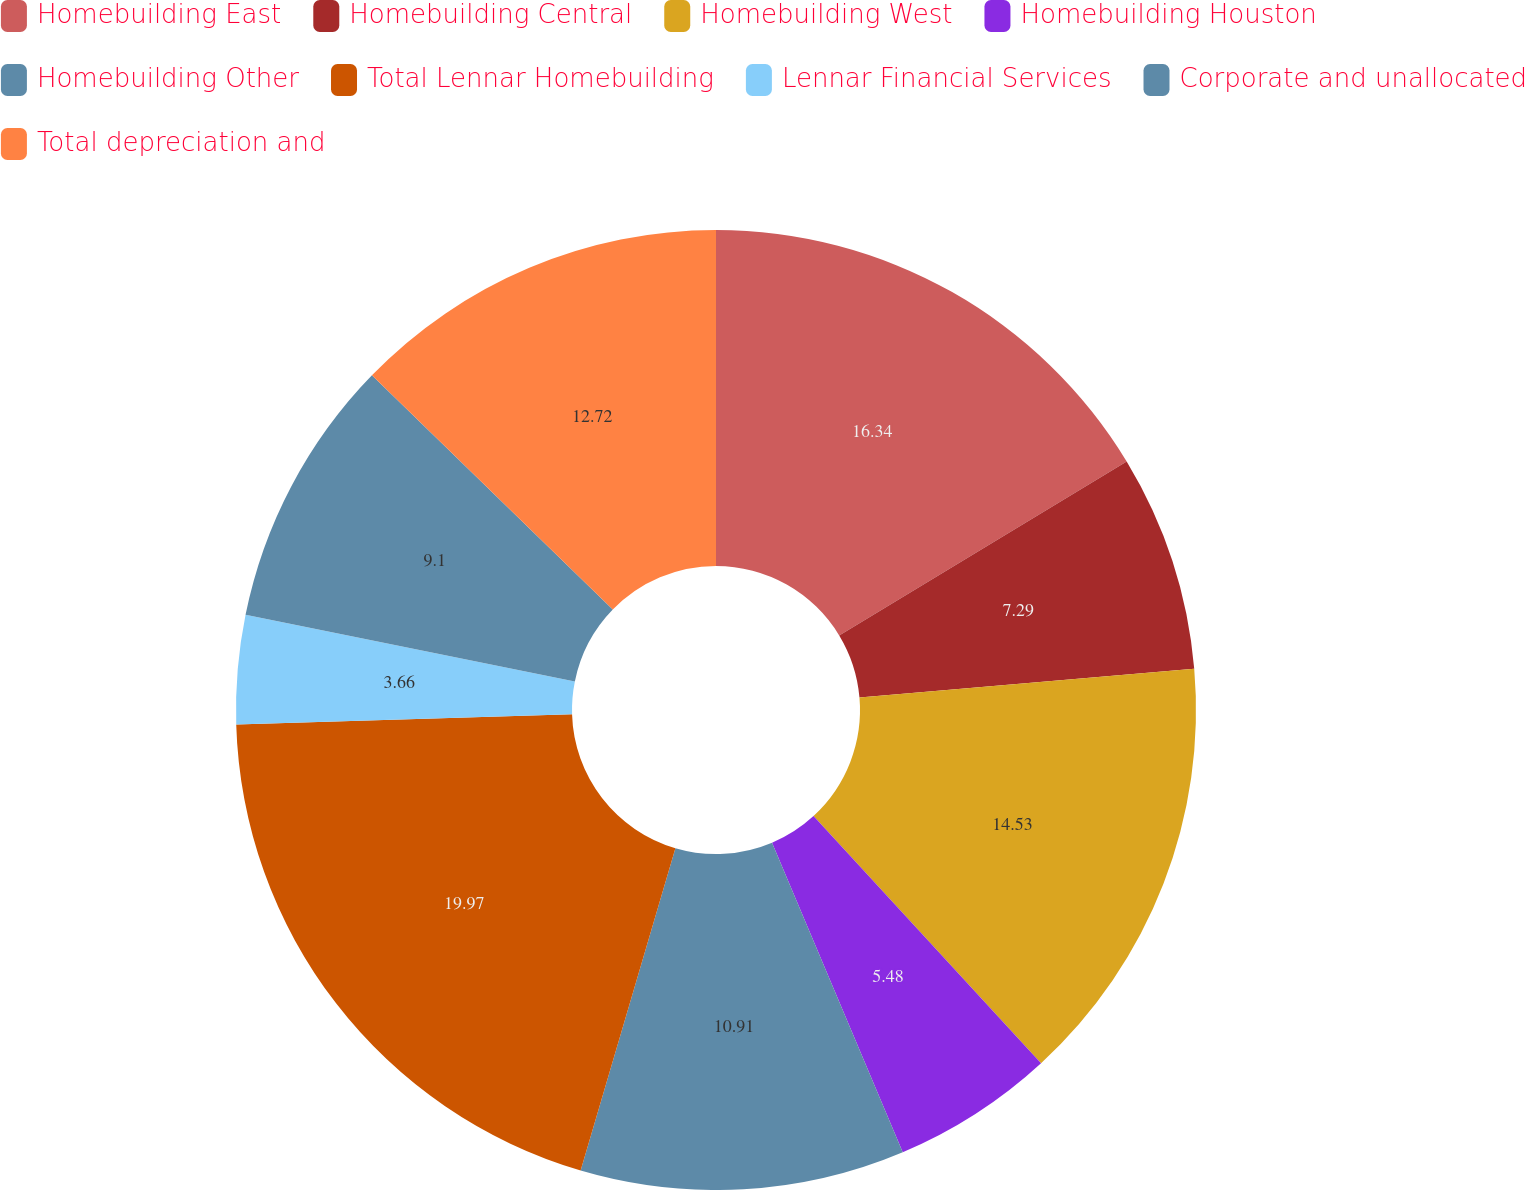Convert chart. <chart><loc_0><loc_0><loc_500><loc_500><pie_chart><fcel>Homebuilding East<fcel>Homebuilding Central<fcel>Homebuilding West<fcel>Homebuilding Houston<fcel>Homebuilding Other<fcel>Total Lennar Homebuilding<fcel>Lennar Financial Services<fcel>Corporate and unallocated<fcel>Total depreciation and<nl><fcel>16.34%<fcel>7.29%<fcel>14.53%<fcel>5.48%<fcel>10.91%<fcel>19.97%<fcel>3.66%<fcel>9.1%<fcel>12.72%<nl></chart> 